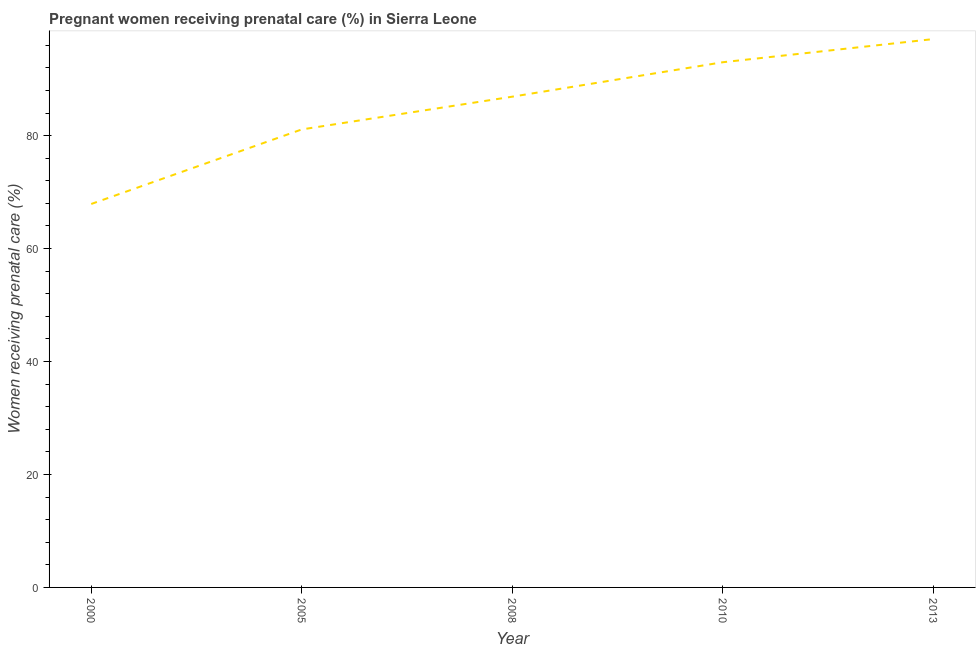What is the percentage of pregnant women receiving prenatal care in 2013?
Your answer should be compact. 97.1. Across all years, what is the maximum percentage of pregnant women receiving prenatal care?
Offer a very short reply. 97.1. Across all years, what is the minimum percentage of pregnant women receiving prenatal care?
Keep it short and to the point. 67.9. In which year was the percentage of pregnant women receiving prenatal care minimum?
Give a very brief answer. 2000. What is the sum of the percentage of pregnant women receiving prenatal care?
Your response must be concise. 426. What is the difference between the percentage of pregnant women receiving prenatal care in 2008 and 2013?
Provide a short and direct response. -10.2. What is the average percentage of pregnant women receiving prenatal care per year?
Make the answer very short. 85.2. What is the median percentage of pregnant women receiving prenatal care?
Keep it short and to the point. 86.9. Do a majority of the years between 2000 and 2005 (inclusive) have percentage of pregnant women receiving prenatal care greater than 40 %?
Your answer should be compact. Yes. What is the ratio of the percentage of pregnant women receiving prenatal care in 2000 to that in 2013?
Offer a terse response. 0.7. What is the difference between the highest and the second highest percentage of pregnant women receiving prenatal care?
Your answer should be very brief. 4.1. Is the sum of the percentage of pregnant women receiving prenatal care in 2010 and 2013 greater than the maximum percentage of pregnant women receiving prenatal care across all years?
Give a very brief answer. Yes. What is the difference between the highest and the lowest percentage of pregnant women receiving prenatal care?
Keep it short and to the point. 29.2. How many years are there in the graph?
Make the answer very short. 5. What is the difference between two consecutive major ticks on the Y-axis?
Your response must be concise. 20. Does the graph contain any zero values?
Your answer should be compact. No. What is the title of the graph?
Keep it short and to the point. Pregnant women receiving prenatal care (%) in Sierra Leone. What is the label or title of the X-axis?
Give a very brief answer. Year. What is the label or title of the Y-axis?
Ensure brevity in your answer.  Women receiving prenatal care (%). What is the Women receiving prenatal care (%) in 2000?
Ensure brevity in your answer.  67.9. What is the Women receiving prenatal care (%) of 2005?
Provide a succinct answer. 81.1. What is the Women receiving prenatal care (%) of 2008?
Make the answer very short. 86.9. What is the Women receiving prenatal care (%) of 2010?
Ensure brevity in your answer.  93. What is the Women receiving prenatal care (%) in 2013?
Your response must be concise. 97.1. What is the difference between the Women receiving prenatal care (%) in 2000 and 2008?
Provide a succinct answer. -19. What is the difference between the Women receiving prenatal care (%) in 2000 and 2010?
Provide a succinct answer. -25.1. What is the difference between the Women receiving prenatal care (%) in 2000 and 2013?
Offer a very short reply. -29.2. What is the difference between the Women receiving prenatal care (%) in 2005 and 2008?
Ensure brevity in your answer.  -5.8. What is the difference between the Women receiving prenatal care (%) in 2005 and 2010?
Offer a very short reply. -11.9. What is the ratio of the Women receiving prenatal care (%) in 2000 to that in 2005?
Give a very brief answer. 0.84. What is the ratio of the Women receiving prenatal care (%) in 2000 to that in 2008?
Offer a terse response. 0.78. What is the ratio of the Women receiving prenatal care (%) in 2000 to that in 2010?
Make the answer very short. 0.73. What is the ratio of the Women receiving prenatal care (%) in 2000 to that in 2013?
Your response must be concise. 0.7. What is the ratio of the Women receiving prenatal care (%) in 2005 to that in 2008?
Make the answer very short. 0.93. What is the ratio of the Women receiving prenatal care (%) in 2005 to that in 2010?
Give a very brief answer. 0.87. What is the ratio of the Women receiving prenatal care (%) in 2005 to that in 2013?
Ensure brevity in your answer.  0.83. What is the ratio of the Women receiving prenatal care (%) in 2008 to that in 2010?
Your response must be concise. 0.93. What is the ratio of the Women receiving prenatal care (%) in 2008 to that in 2013?
Provide a short and direct response. 0.9. What is the ratio of the Women receiving prenatal care (%) in 2010 to that in 2013?
Offer a terse response. 0.96. 